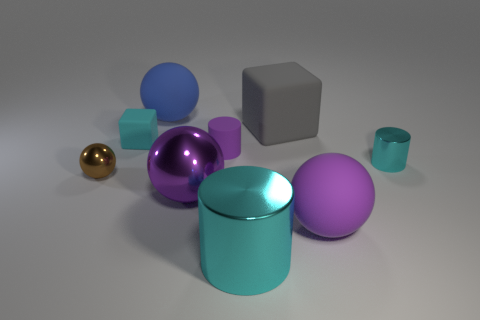There is a metallic sphere on the right side of the cyan matte thing; is its size the same as the big cyan metallic cylinder?
Provide a short and direct response. Yes. There is another ball that is the same color as the big shiny sphere; what is its size?
Offer a very short reply. Large. Is there a cyan matte object of the same size as the purple rubber cylinder?
Offer a terse response. Yes. There is a small shiny thing that is right of the tiny metal sphere; does it have the same color as the shiny cylinder that is in front of the small cyan metal cylinder?
Offer a very short reply. Yes. Is there a shiny cylinder of the same color as the tiny rubber cylinder?
Make the answer very short. No. What number of other things are there of the same shape as the big cyan metallic thing?
Keep it short and to the point. 2. What is the shape of the large blue thing that is on the right side of the small cube?
Make the answer very short. Sphere. There is a large purple matte thing; is it the same shape as the cyan thing left of the big blue sphere?
Offer a terse response. No. There is a rubber thing that is behind the cyan matte object and in front of the large blue thing; what size is it?
Keep it short and to the point. Large. There is a sphere that is both on the right side of the big blue rubber object and behind the purple rubber ball; what color is it?
Give a very brief answer. Purple. 